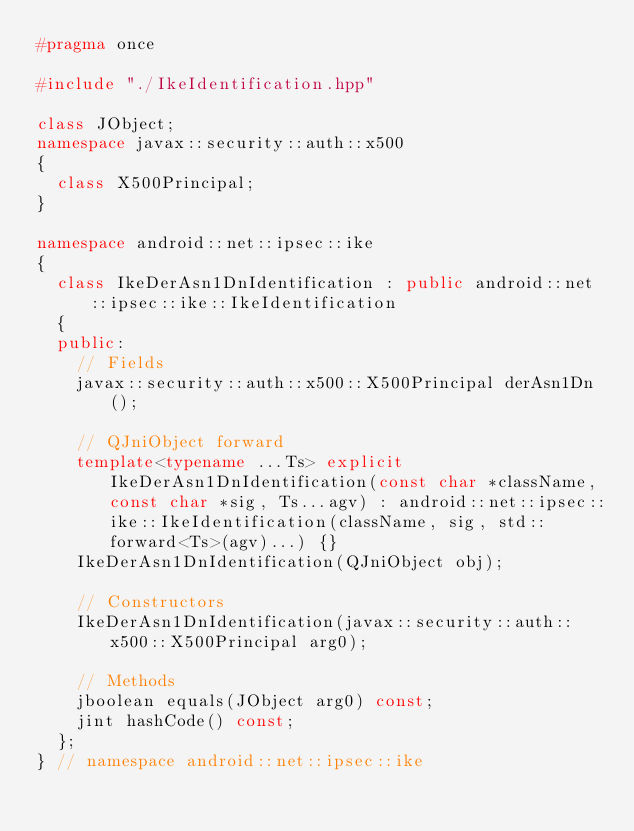<code> <loc_0><loc_0><loc_500><loc_500><_C++_>#pragma once

#include "./IkeIdentification.hpp"

class JObject;
namespace javax::security::auth::x500
{
	class X500Principal;
}

namespace android::net::ipsec::ike
{
	class IkeDerAsn1DnIdentification : public android::net::ipsec::ike::IkeIdentification
	{
	public:
		// Fields
		javax::security::auth::x500::X500Principal derAsn1Dn();
		
		// QJniObject forward
		template<typename ...Ts> explicit IkeDerAsn1DnIdentification(const char *className, const char *sig, Ts...agv) : android::net::ipsec::ike::IkeIdentification(className, sig, std::forward<Ts>(agv)...) {}
		IkeDerAsn1DnIdentification(QJniObject obj);
		
		// Constructors
		IkeDerAsn1DnIdentification(javax::security::auth::x500::X500Principal arg0);
		
		// Methods
		jboolean equals(JObject arg0) const;
		jint hashCode() const;
	};
} // namespace android::net::ipsec::ike

</code> 